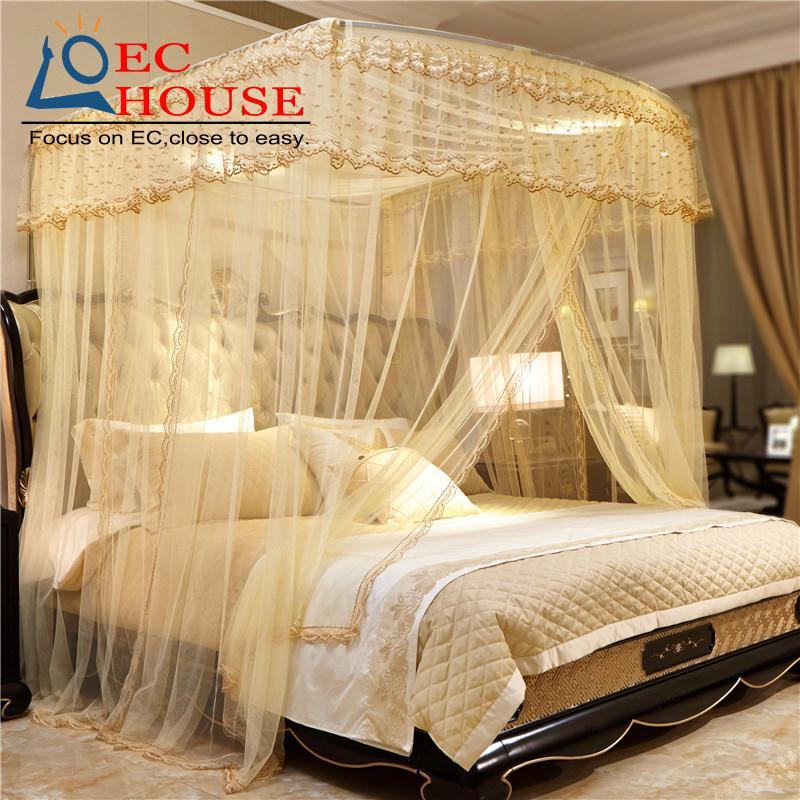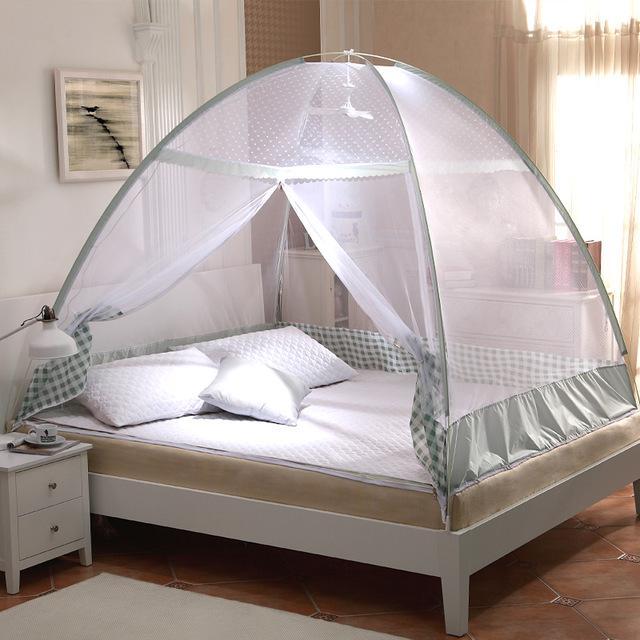The first image is the image on the left, the second image is the image on the right. Considering the images on both sides, is "There is a rounded net sitting over the bed in the image on the right." valid? Answer yes or no. Yes. The first image is the image on the left, the second image is the image on the right. Assess this claim about the two images: "Drapes cover half of the bed in the left image and a tent like dome covers the whole bed in the right image.". Correct or not? Answer yes or no. Yes. 